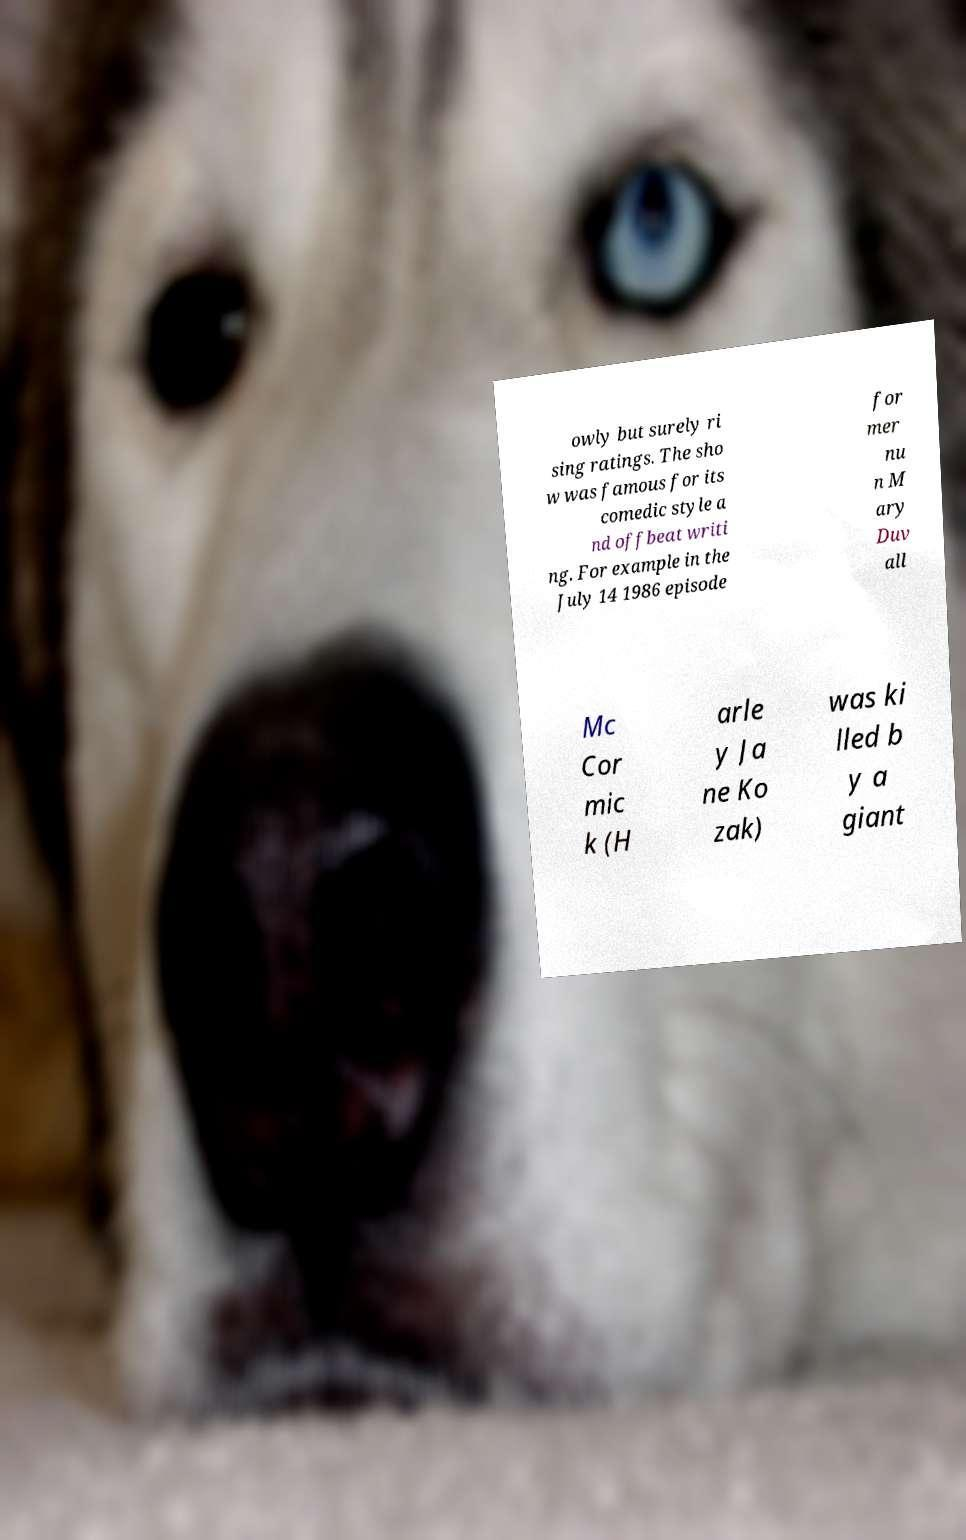What messages or text are displayed in this image? I need them in a readable, typed format. owly but surely ri sing ratings. The sho w was famous for its comedic style a nd offbeat writi ng. For example in the July 14 1986 episode for mer nu n M ary Duv all Mc Cor mic k (H arle y Ja ne Ko zak) was ki lled b y a giant 